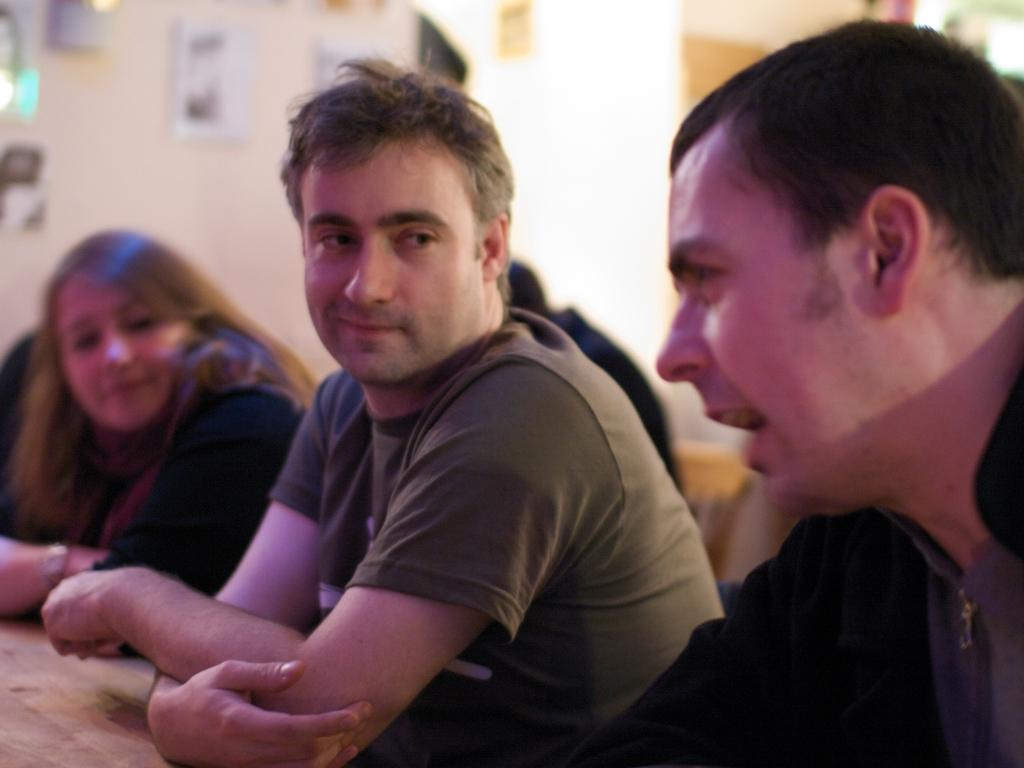Who is the person on the right side of the image? There is a man on the right side of the image. What is the man on the right side doing? The man on the right side is speaking. Who is the person in the middle of the image? There is another man in the man in the middle of the image. Who is the person on the left side of the image? There is a woman on the left side of the image. What color is the top worn by the woman on the left side? The woman is wearing a black color top. What type of chess piece is the woman holding in the image? There is no chess piece present in the image. How many twigs can be seen on the ground in the image? There is no mention of twigs or any ground in the image. 